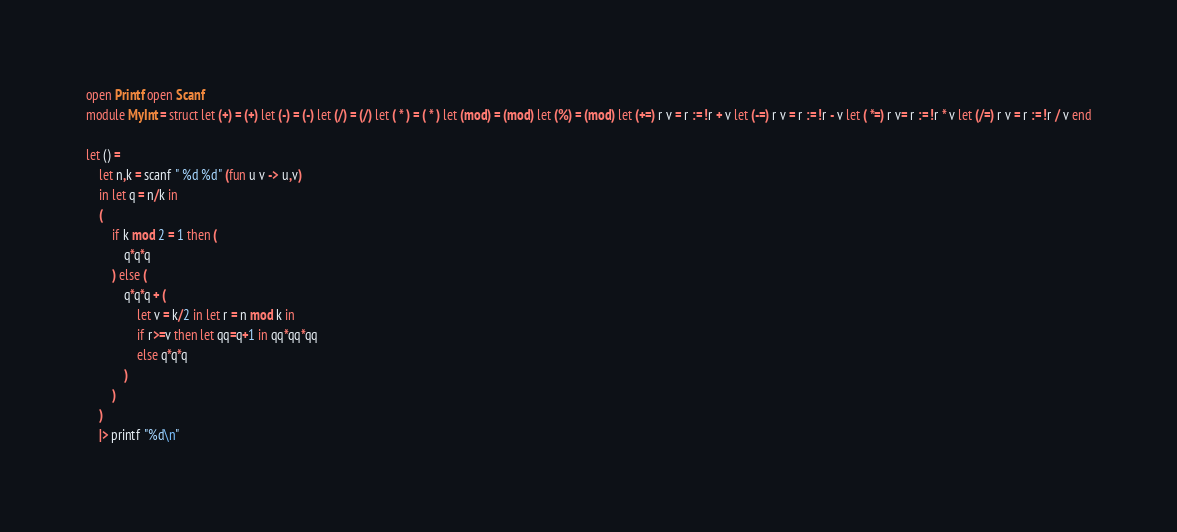<code> <loc_0><loc_0><loc_500><loc_500><_OCaml_>open Printf open Scanf
module MyInt = struct let (+) = (+) let (-) = (-) let (/) = (/) let ( * ) = ( * ) let (mod) = (mod) let (%) = (mod) let (+=) r v = r := !r + v let (-=) r v = r := !r - v let ( *=) r v= r := !r * v let (/=) r v = r := !r / v end

let () =
	let n,k = scanf " %d %d" (fun u v -> u,v)
	in let q = n/k in
	(
		if k mod 2 = 1 then (
			q*q*q
		) else (
			q*q*q + (
				let v = k/2 in let r = n mod k in
				if r>=v then let qq=q+1 in qq*qq*qq
				else q*q*q
			)
		)
	)
	|> printf "%d\n"</code> 